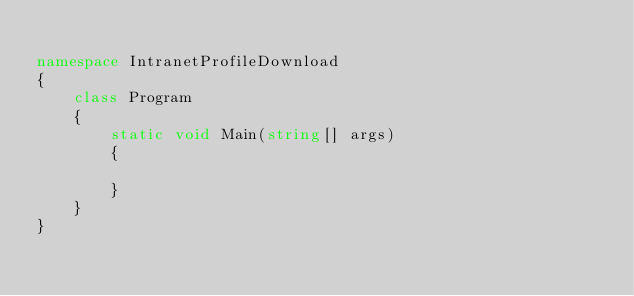Convert code to text. <code><loc_0><loc_0><loc_500><loc_500><_C#_>
namespace IntranetProfileDownload
{
    class Program
    {
        static void Main(string[] args)
        {

        }
    }
}
</code> 